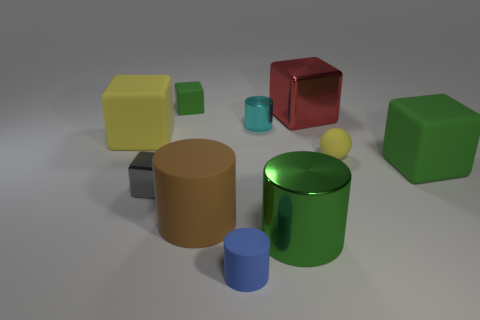What is the material of the green cube on the right side of the big metal object behind the small metallic cube?
Your answer should be very brief. Rubber. How many things are either rubber cubes on the left side of the red metal cube or small green rubber things?
Provide a succinct answer. 2. Are there an equal number of red metal cubes that are in front of the big yellow rubber object and big red things that are on the left side of the brown rubber cylinder?
Offer a very short reply. Yes. What material is the green block to the left of the metallic thing in front of the gray thing on the left side of the brown rubber object made of?
Your response must be concise. Rubber. What is the size of the shiny thing that is right of the cyan metallic object and in front of the yellow matte cube?
Your response must be concise. Large. Does the blue thing have the same shape as the small cyan metallic object?
Your answer should be compact. Yes. There is a green thing that is made of the same material as the tiny cyan cylinder; what is its shape?
Offer a very short reply. Cylinder. What number of big objects are either blue objects or balls?
Offer a very short reply. 0. Are there any rubber blocks that are in front of the small cylinder in front of the gray block?
Make the answer very short. No. Are there any purple cylinders?
Provide a succinct answer. No. 